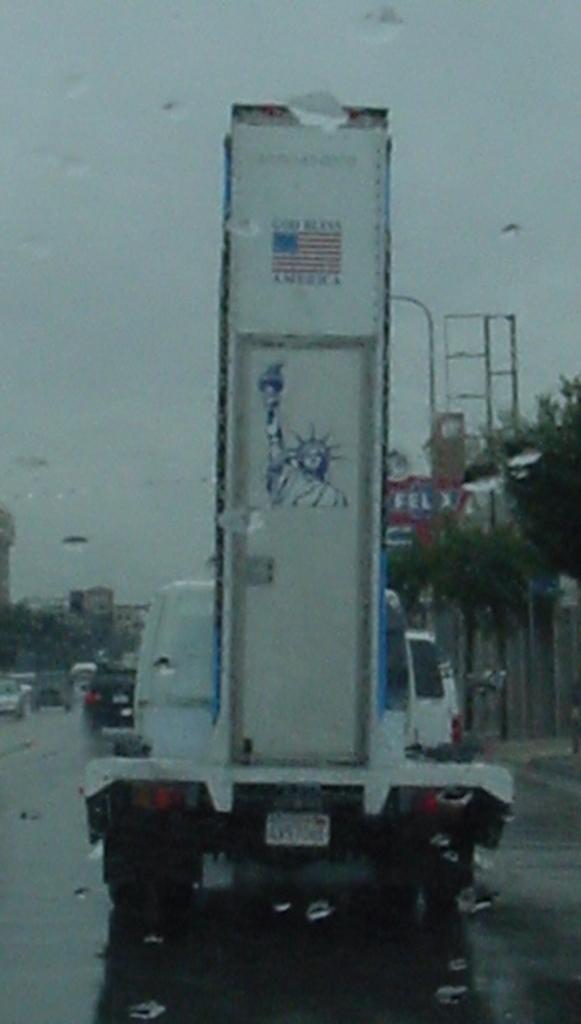Could you give a brief overview of what you see in this image? Here in this picture, in the front we can see a glass present and on that we can see some water droplets present and through that we can see number of vehicles present on the road and in the middle we can see a truck, on which we can see something present on it and we can also see light posts, plants and trees present and we can see the sky is cloudy. 